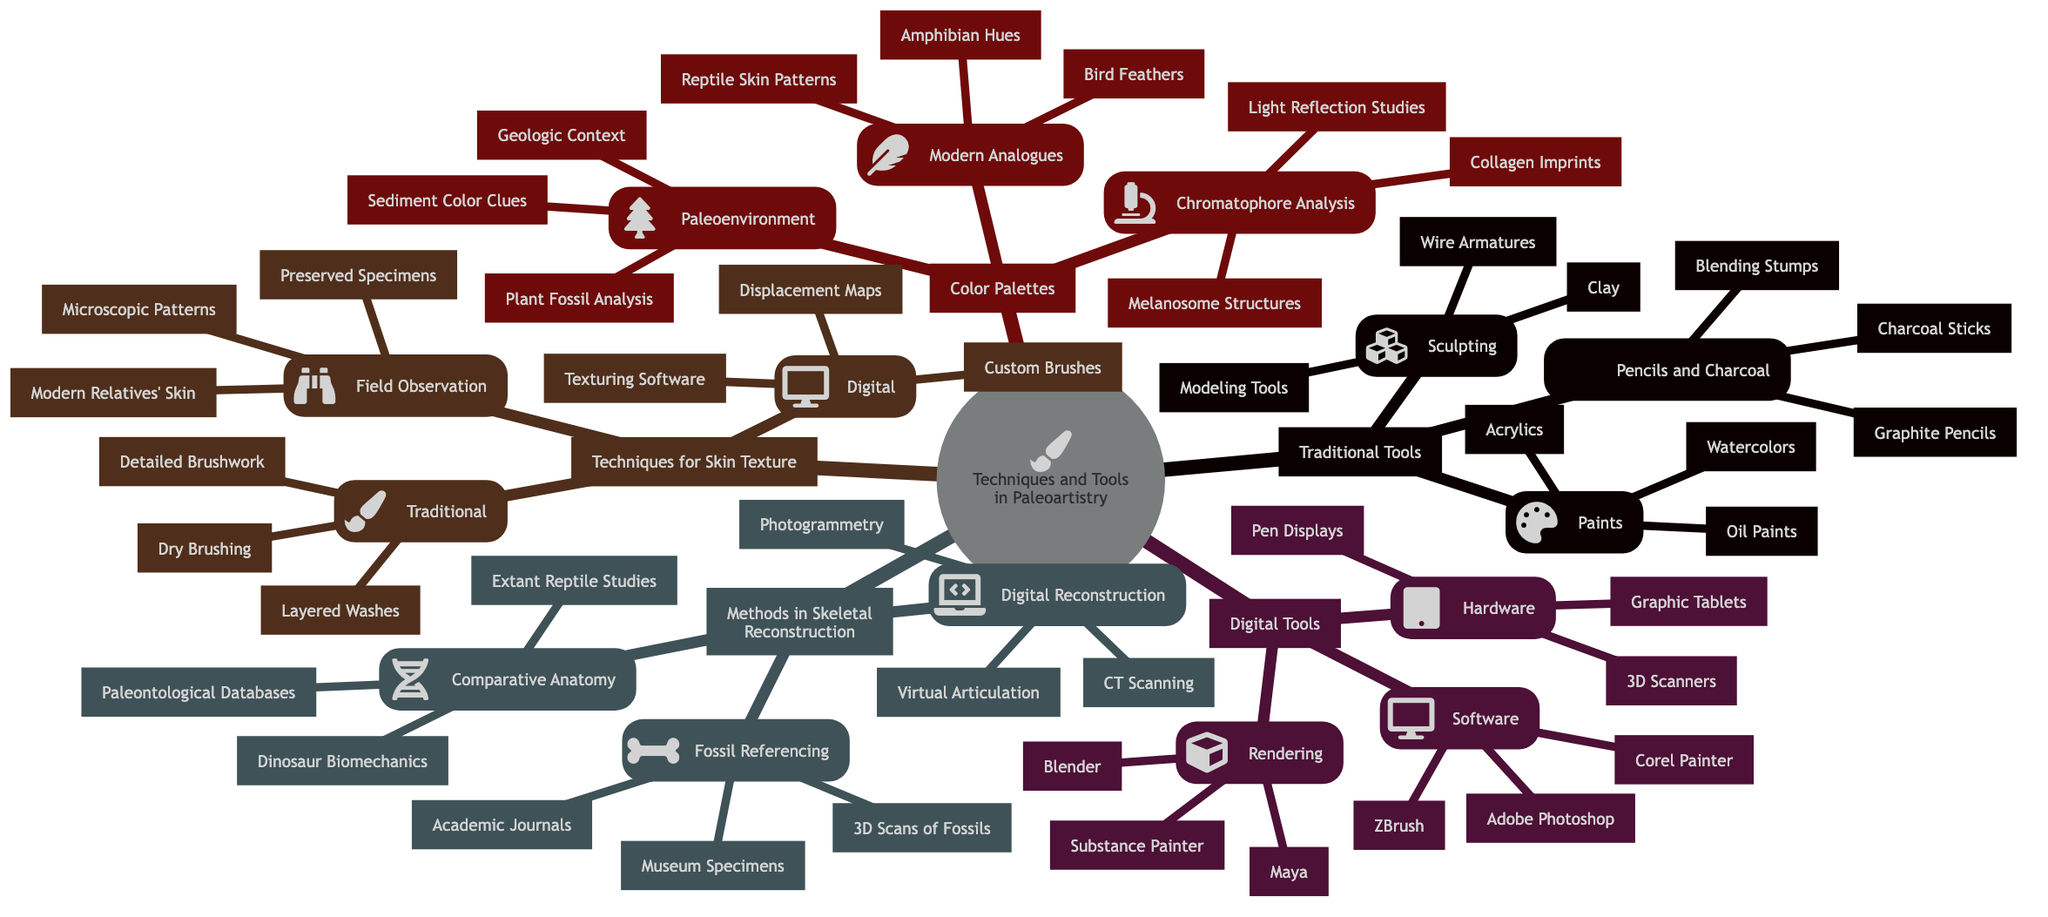What are the three types of traditional painting tools listed in the diagram? The first main branch under "Traditional Tools" is "Paints," which contains three items: Acrylics, Watercolors, and Oil Paints. The question refers specifically to painting tools, so the answer is confined to these three types.
Answer: Acrylics, Watercolors, Oil Paints What method in skeletal reconstruction involves examining modern reptiles? The second main branch, "Methods in Skeletal Reconstruction," includes "Comparative Anatomy," one of its components is "Extant Reptile Studies," which emphasizes examining modern reptiles to understand prehistoric species.
Answer: Extant Reptile Studies Which digital rendering software is included in the diagram? Under the "Digital Tools" section, the subcategory "Rendering" lists three software options: Blender, Maya, and Substance Painter. The question inquires about any software related to digital rendering, and all three options apply here.
Answer: Blender, Maya, Substance Painter How many traditional techniques for skin texture representation are provided? In the "Techniques for Skin Texture Representation" section, under the "Traditional" subcategory, there are three techniques mentioned: Detailed Brushwork, Dry Brushing, and Layered Washes. The question seeks the count of these techniques.
Answer: 3 What is the primary analytical method for color palettes based on scientific evidence? In the "Color Palettes Based on Scientific Evidence" section, the first main branch is "Chromatophore Analysis," which is recognized as a primary analytical method for understanding color palettes.
Answer: Chromatophore Analysis What do digital tools utilize for creating art? The "Digital Tools" section breaks down into Software, Hardware, and Rendering, which indicates that digital tools consist of various means for creation like applications and devices.
Answer: Software, Hardware, Rendering Which traditional sculpting material is mentioned in the diagram? In the "Traditional Tools" section, the category "Sculpting" includes Clay, which is a traditional material used in sculpting. The question specifies "material," which directs the answer to one specific item from that category.
Answer: Clay What type of observation includes modern relatives' skin in texture representation techniques? In the "Techniques for Skin Texture Representation" section, under "Field Observation," one component listed is "Modern Relatives' Skin," which relates this type of observation directly to modern species.
Answer: Modern Relatives' Skin 